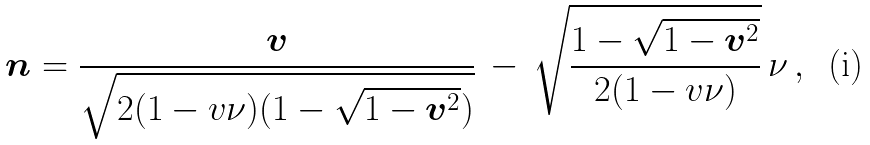Convert formula to latex. <formula><loc_0><loc_0><loc_500><loc_500>\boldsymbol n = \frac { \boldsymbol v } { \sqrt { 2 ( 1 - v \nu ) ( 1 - \sqrt { 1 - { \boldsymbol v } ^ { 2 } } ) } } \, - \, \sqrt { \frac { 1 - \sqrt { 1 - { \boldsymbol v } ^ { 2 } } } { 2 ( 1 - v \nu ) } } \, \nu \, ,</formula> 